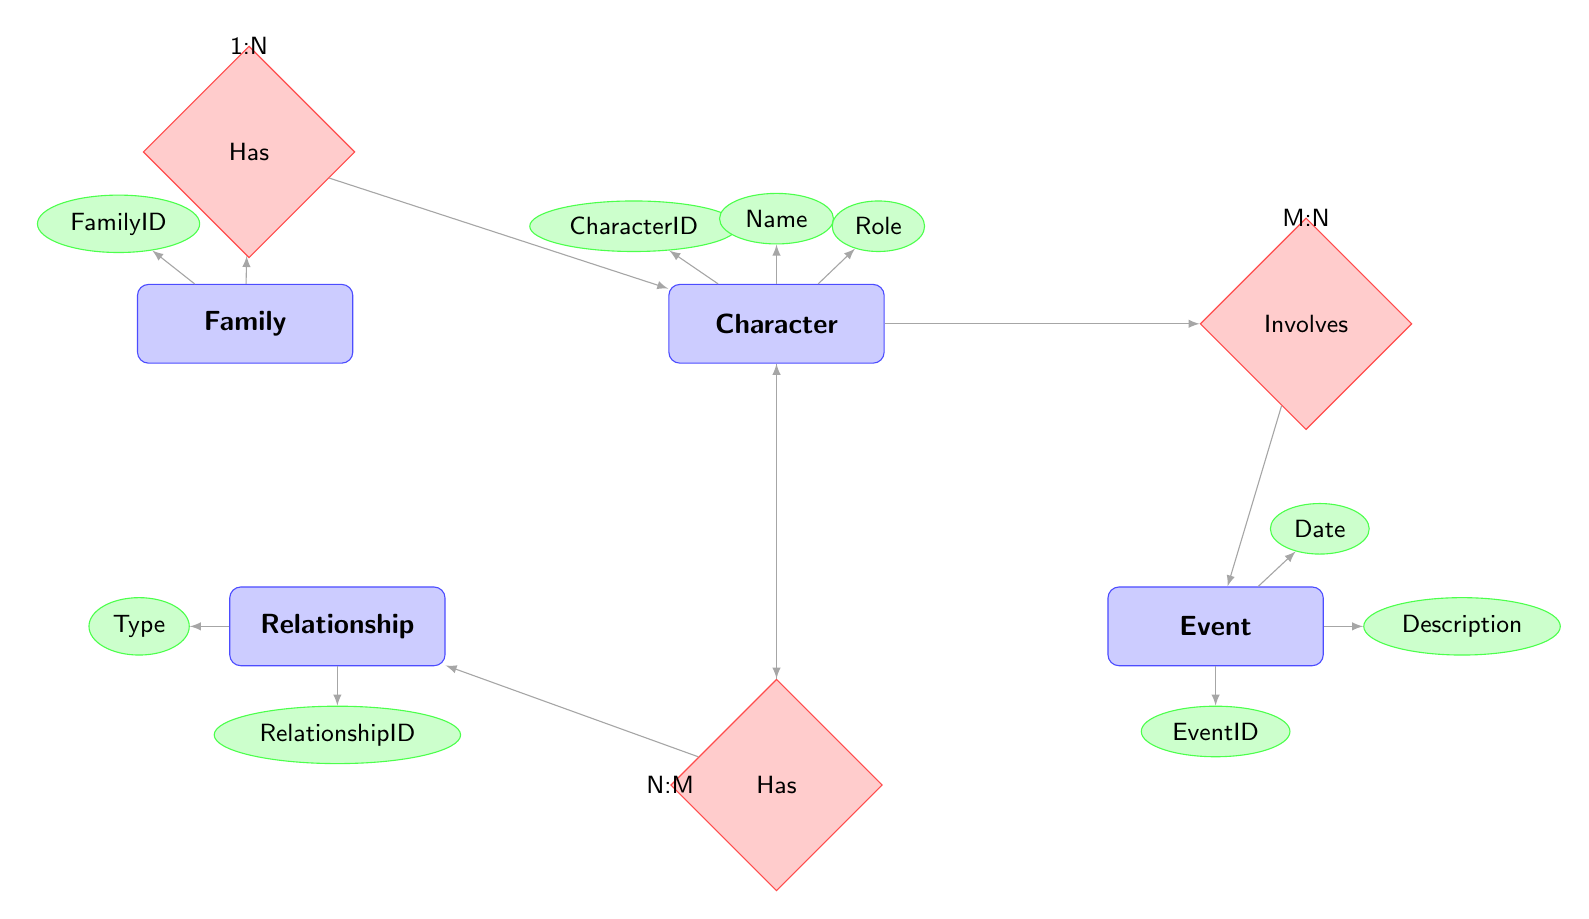What is the FamilyID for "The Knotts"? The diagram indicates that "The Knotts" is a family represented by an entity that has an attribute FamilyID, which in the example is shown as 1.
Answer: 1 How many characters are involved in the relationship "Siblings"? By examining the "Character_Has_Relationship_With_Character" relationship, we can see that it connects two instances of the Character entity, indicating this relationship involves two characters.
Answer: 2 What is the type of relationship between Thelonious Ellison and another character? According to the relationship entity in the diagram, Thelonious Ellison has a relationship categorized as "Siblings" with another character, which is noted under the Type attribute of the Relationship entity.
Answer: Siblings How many events are indicated in the diagram? The diagram has a single Event entity example, illustrating one event that involves a character, thus there is only one event represented.
Answer: 1 What is the main character in "The Family in God's Country"? The diagram shows that "Moses" is identified as the Main Character in the example pertaining to the family "The Family in God's Country."
Answer: Moses Identify the Type attribute of the relationship involving Moses. By observing the example relating to Moses, we can see the Type attribute for his relationship is designated as "Father-Son" as provided in the Relationship entity linked to Moses in the diagram.
Answer: Father-Son What is the cardinality of the relationship between Family and Character? In the diagram, the relationship "Family_Has_Character" is designated with cardinality 1:N, indicating that one family can have multiple characters associated with it.
Answer: 1:N How many types of relationships exist in the diagram? The diagram lists one type of relationship as an attribute in the Relationship entity, specifically noted to be "Siblings" and "Father-Son," which means two unique types of relationships are represented in the examples.
Answer: 2 What is the description of the event involving Thelonious Ellison? The event associated with Thelonious Ellison is described in the diagram as "Publication of Novel 'Erasure'", which clearly states the event's significance.
Answer: Publication of Novel 'Erasure' 